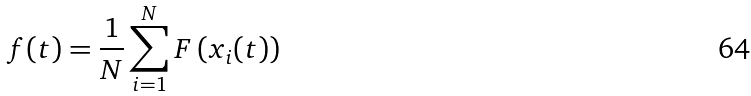Convert formula to latex. <formula><loc_0><loc_0><loc_500><loc_500>f ( t ) = \frac { 1 } { N } \sum _ { i = 1 } ^ { N } F \left ( x _ { i } ( t ) \right )</formula> 